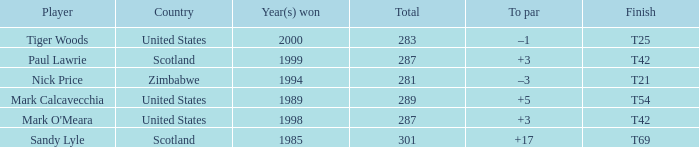What is Tiger Woods' to par? –1. 